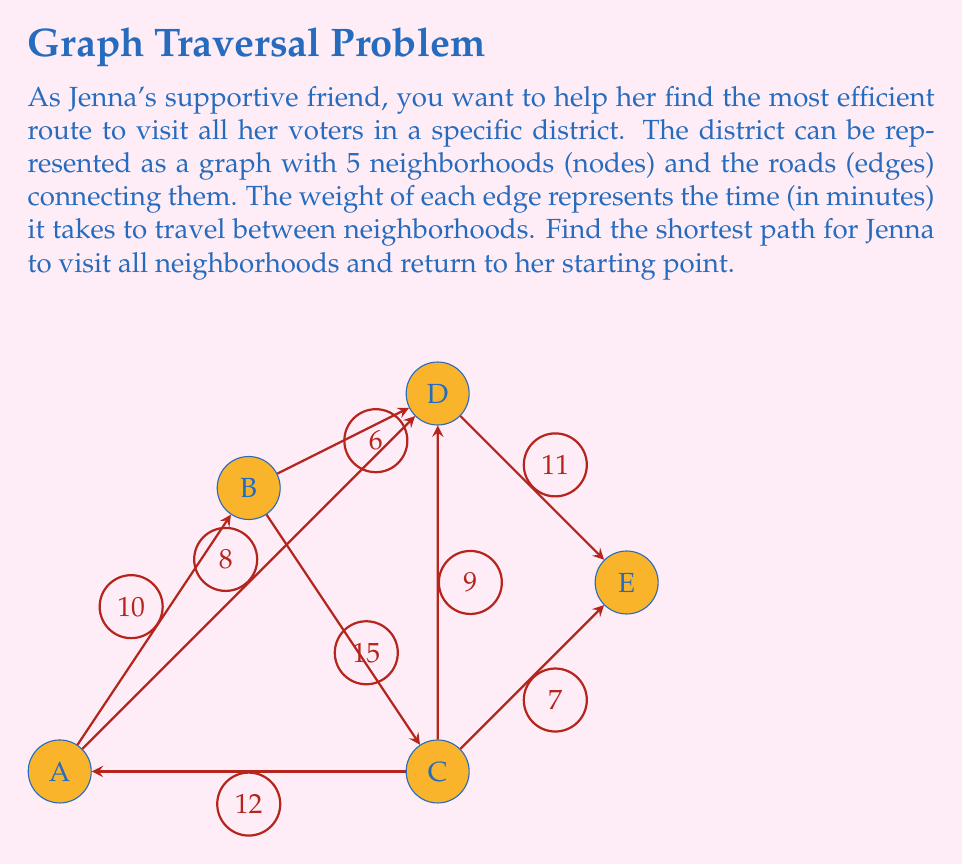What is the answer to this math problem? To solve this problem, we need to find the shortest Hamiltonian cycle in the given graph, which is known as the Traveling Salesman Problem (TSP). For a small graph like this, we can use a brute-force approach to find the optimal solution.

Step 1: List all possible Hamiltonian cycles.
There are $(5-1)! = 24$ possible cycles starting and ending at A.

Step 2: Calculate the total time for each cycle.
Let's calculate a few examples:

1. A-B-C-D-E-A: $10 + 15 + 9 + 11 + 12 = 57$ minutes
2. A-B-D-C-E-A: $10 + 6 + 9 + 7 + 12 = 44$ minutes
3. A-C-B-D-E-A: $12 + 15 + 6 + 11 + 12 = 56$ minutes

Step 3: Compare all cycles and find the shortest one.
After calculating all 24 cycles, we find that the shortest path is:

A-B-D-E-C-A with a total time of $10 + 6 + 11 + 7 + 12 = 46$ minutes

Step 4: Verify the solution.
We can confirm that this path visits all neighborhoods exactly once and returns to the starting point A.

Therefore, the shortest path for Jenna to visit all voters in the district is A-B-D-E-C-A, taking 46 minutes in total.
Answer: A-B-D-E-C-A, 46 minutes 